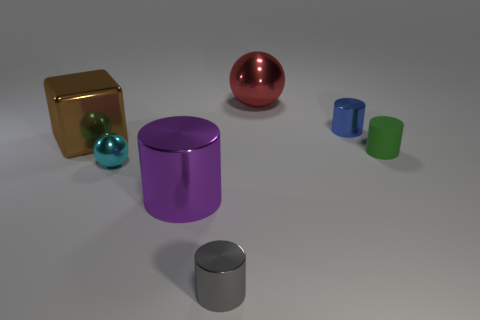Subtract 1 cylinders. How many cylinders are left? 3 Add 2 tiny cylinders. How many objects exist? 9 Subtract all spheres. How many objects are left? 5 Add 3 small gray shiny things. How many small gray shiny things are left? 4 Add 4 tiny purple rubber cylinders. How many tiny purple rubber cylinders exist? 4 Subtract 1 brown blocks. How many objects are left? 6 Subtract all brown metallic things. Subtract all cylinders. How many objects are left? 2 